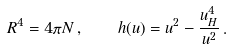Convert formula to latex. <formula><loc_0><loc_0><loc_500><loc_500>R ^ { 4 } = 4 \pi N \, , \quad h ( u ) = u ^ { 2 } - \frac { u _ { H } ^ { 4 } } { u ^ { 2 } } \, .</formula> 